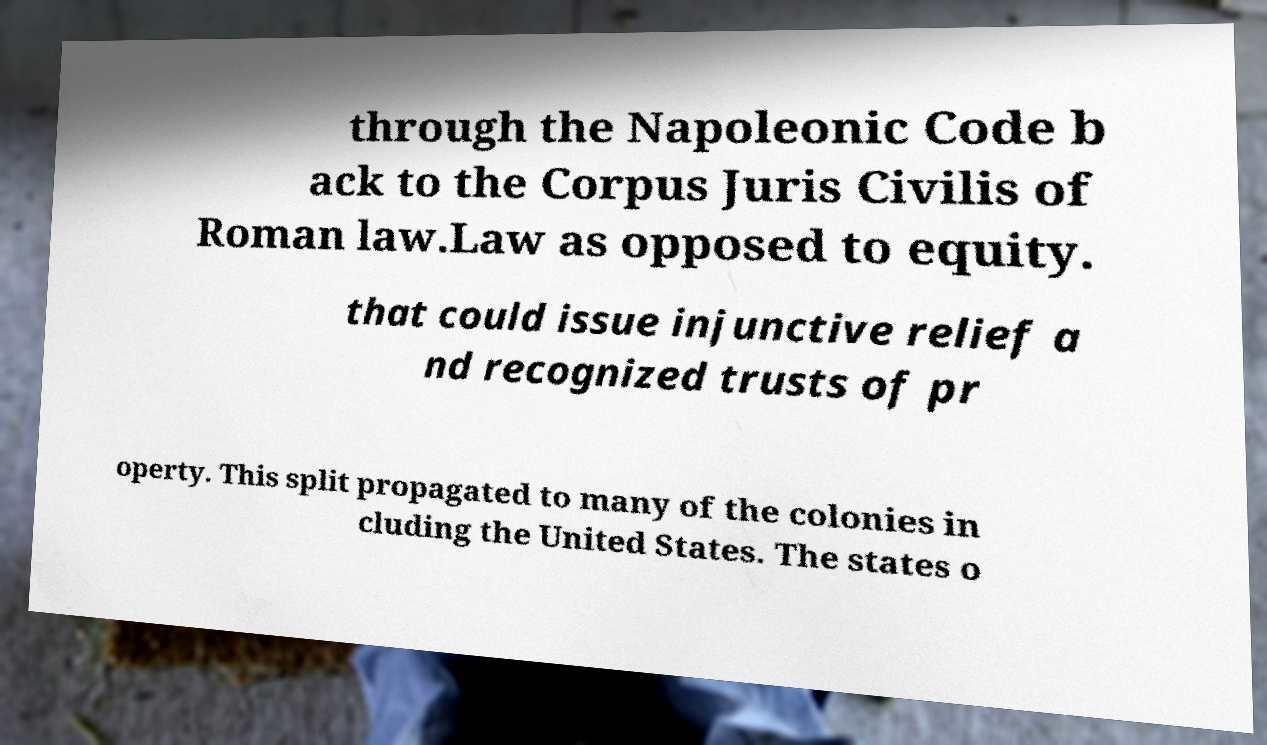Please identify and transcribe the text found in this image. through the Napoleonic Code b ack to the Corpus Juris Civilis of Roman law.Law as opposed to equity. that could issue injunctive relief a nd recognized trusts of pr operty. This split propagated to many of the colonies in cluding the United States. The states o 